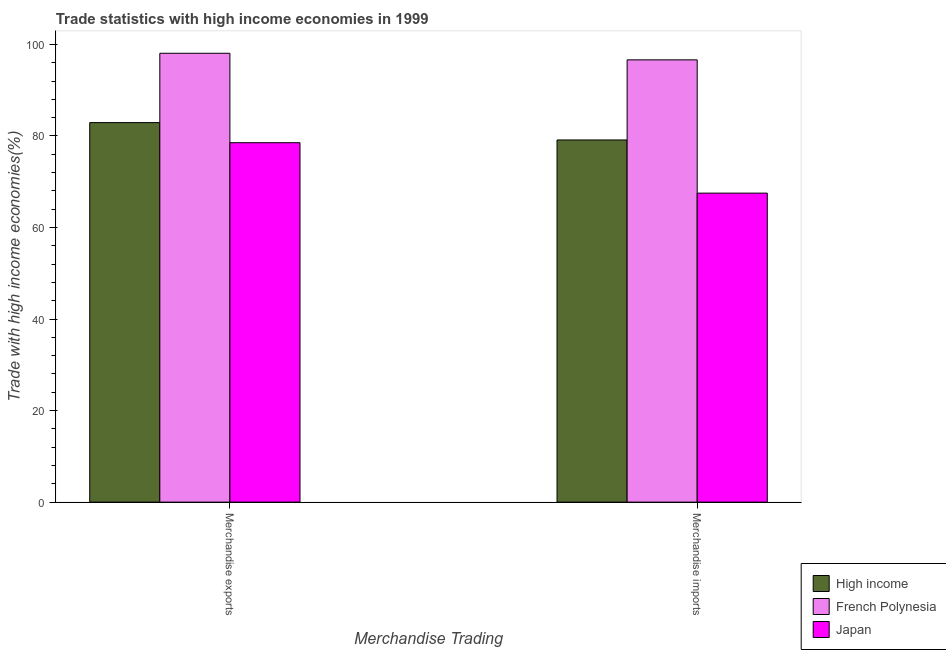How many different coloured bars are there?
Your answer should be compact. 3. Are the number of bars per tick equal to the number of legend labels?
Your answer should be compact. Yes. How many bars are there on the 2nd tick from the right?
Ensure brevity in your answer.  3. What is the label of the 1st group of bars from the left?
Offer a terse response. Merchandise exports. What is the merchandise exports in High income?
Offer a terse response. 82.92. Across all countries, what is the maximum merchandise exports?
Your answer should be compact. 98.07. Across all countries, what is the minimum merchandise exports?
Your response must be concise. 78.52. In which country was the merchandise exports maximum?
Your answer should be very brief. French Polynesia. What is the total merchandise exports in the graph?
Offer a very short reply. 259.51. What is the difference between the merchandise imports in French Polynesia and that in Japan?
Offer a terse response. 29.12. What is the difference between the merchandise exports in Japan and the merchandise imports in French Polynesia?
Keep it short and to the point. -18.1. What is the average merchandise imports per country?
Your response must be concise. 81.09. What is the difference between the merchandise exports and merchandise imports in Japan?
Offer a very short reply. 11.02. What is the ratio of the merchandise exports in French Polynesia to that in High income?
Offer a terse response. 1.18. Is the merchandise exports in French Polynesia less than that in Japan?
Offer a very short reply. No. In how many countries, is the merchandise exports greater than the average merchandise exports taken over all countries?
Keep it short and to the point. 1. What does the 2nd bar from the right in Merchandise imports represents?
Offer a very short reply. French Polynesia. Are all the bars in the graph horizontal?
Keep it short and to the point. No. How many countries are there in the graph?
Your response must be concise. 3. What is the difference between two consecutive major ticks on the Y-axis?
Give a very brief answer. 20. Are the values on the major ticks of Y-axis written in scientific E-notation?
Make the answer very short. No. Where does the legend appear in the graph?
Your response must be concise. Bottom right. How are the legend labels stacked?
Keep it short and to the point. Vertical. What is the title of the graph?
Your answer should be very brief. Trade statistics with high income economies in 1999. What is the label or title of the X-axis?
Offer a terse response. Merchandise Trading. What is the label or title of the Y-axis?
Make the answer very short. Trade with high income economies(%). What is the Trade with high income economies(%) of High income in Merchandise exports?
Your answer should be compact. 82.92. What is the Trade with high income economies(%) of French Polynesia in Merchandise exports?
Make the answer very short. 98.07. What is the Trade with high income economies(%) of Japan in Merchandise exports?
Make the answer very short. 78.52. What is the Trade with high income economies(%) of High income in Merchandise imports?
Ensure brevity in your answer.  79.12. What is the Trade with high income economies(%) of French Polynesia in Merchandise imports?
Your answer should be very brief. 96.63. What is the Trade with high income economies(%) in Japan in Merchandise imports?
Give a very brief answer. 67.51. Across all Merchandise Trading, what is the maximum Trade with high income economies(%) in High income?
Offer a very short reply. 82.92. Across all Merchandise Trading, what is the maximum Trade with high income economies(%) in French Polynesia?
Give a very brief answer. 98.07. Across all Merchandise Trading, what is the maximum Trade with high income economies(%) of Japan?
Give a very brief answer. 78.52. Across all Merchandise Trading, what is the minimum Trade with high income economies(%) of High income?
Give a very brief answer. 79.12. Across all Merchandise Trading, what is the minimum Trade with high income economies(%) in French Polynesia?
Your answer should be very brief. 96.63. Across all Merchandise Trading, what is the minimum Trade with high income economies(%) of Japan?
Ensure brevity in your answer.  67.51. What is the total Trade with high income economies(%) in High income in the graph?
Offer a terse response. 162.04. What is the total Trade with high income economies(%) in French Polynesia in the graph?
Your answer should be very brief. 194.69. What is the total Trade with high income economies(%) of Japan in the graph?
Make the answer very short. 146.03. What is the difference between the Trade with high income economies(%) of High income in Merchandise exports and that in Merchandise imports?
Make the answer very short. 3.79. What is the difference between the Trade with high income economies(%) in French Polynesia in Merchandise exports and that in Merchandise imports?
Ensure brevity in your answer.  1.44. What is the difference between the Trade with high income economies(%) of Japan in Merchandise exports and that in Merchandise imports?
Your response must be concise. 11.02. What is the difference between the Trade with high income economies(%) in High income in Merchandise exports and the Trade with high income economies(%) in French Polynesia in Merchandise imports?
Provide a short and direct response. -13.71. What is the difference between the Trade with high income economies(%) of High income in Merchandise exports and the Trade with high income economies(%) of Japan in Merchandise imports?
Keep it short and to the point. 15.41. What is the difference between the Trade with high income economies(%) of French Polynesia in Merchandise exports and the Trade with high income economies(%) of Japan in Merchandise imports?
Ensure brevity in your answer.  30.56. What is the average Trade with high income economies(%) in High income per Merchandise Trading?
Offer a terse response. 81.02. What is the average Trade with high income economies(%) in French Polynesia per Merchandise Trading?
Give a very brief answer. 97.35. What is the average Trade with high income economies(%) in Japan per Merchandise Trading?
Ensure brevity in your answer.  73.02. What is the difference between the Trade with high income economies(%) in High income and Trade with high income economies(%) in French Polynesia in Merchandise exports?
Keep it short and to the point. -15.15. What is the difference between the Trade with high income economies(%) of High income and Trade with high income economies(%) of Japan in Merchandise exports?
Provide a succinct answer. 4.39. What is the difference between the Trade with high income economies(%) of French Polynesia and Trade with high income economies(%) of Japan in Merchandise exports?
Your response must be concise. 19.54. What is the difference between the Trade with high income economies(%) of High income and Trade with high income economies(%) of French Polynesia in Merchandise imports?
Offer a very short reply. -17.5. What is the difference between the Trade with high income economies(%) in High income and Trade with high income economies(%) in Japan in Merchandise imports?
Your response must be concise. 11.62. What is the difference between the Trade with high income economies(%) of French Polynesia and Trade with high income economies(%) of Japan in Merchandise imports?
Your answer should be compact. 29.12. What is the ratio of the Trade with high income economies(%) in High income in Merchandise exports to that in Merchandise imports?
Your answer should be compact. 1.05. What is the ratio of the Trade with high income economies(%) in French Polynesia in Merchandise exports to that in Merchandise imports?
Give a very brief answer. 1.01. What is the ratio of the Trade with high income economies(%) of Japan in Merchandise exports to that in Merchandise imports?
Your answer should be compact. 1.16. What is the difference between the highest and the second highest Trade with high income economies(%) in High income?
Your answer should be compact. 3.79. What is the difference between the highest and the second highest Trade with high income economies(%) of French Polynesia?
Your response must be concise. 1.44. What is the difference between the highest and the second highest Trade with high income economies(%) in Japan?
Provide a short and direct response. 11.02. What is the difference between the highest and the lowest Trade with high income economies(%) in High income?
Your response must be concise. 3.79. What is the difference between the highest and the lowest Trade with high income economies(%) of French Polynesia?
Your answer should be very brief. 1.44. What is the difference between the highest and the lowest Trade with high income economies(%) of Japan?
Ensure brevity in your answer.  11.02. 